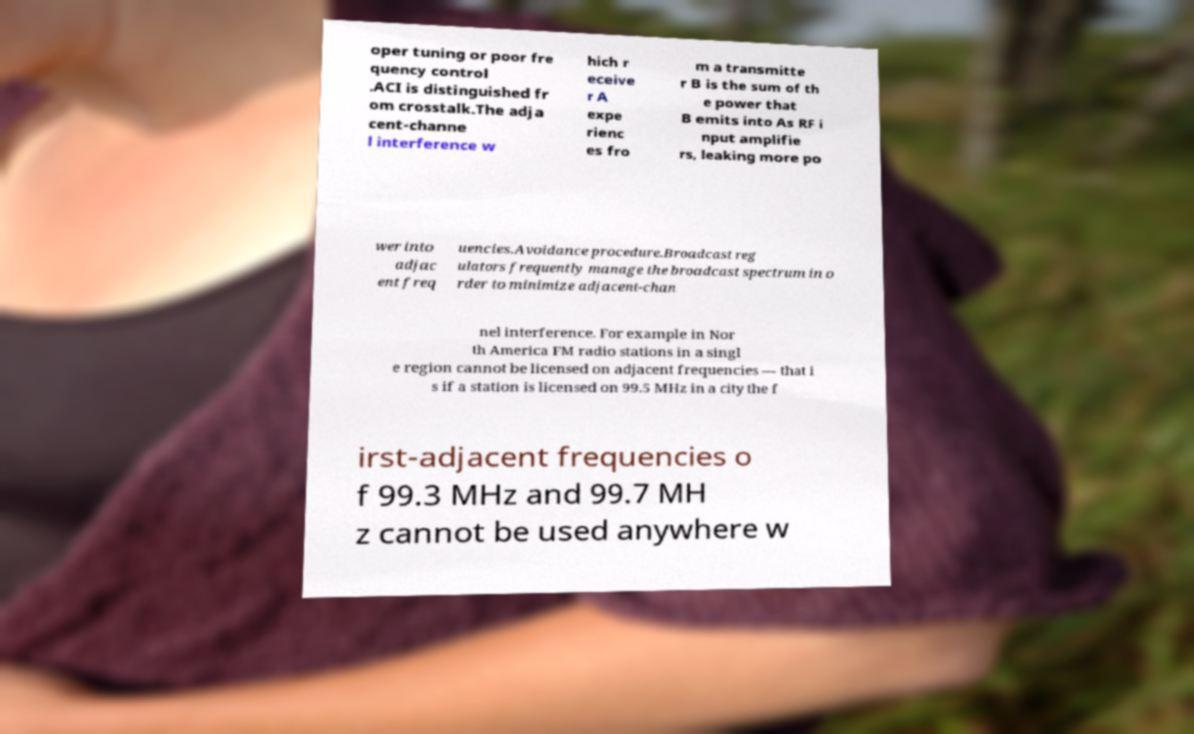Can you read and provide the text displayed in the image?This photo seems to have some interesting text. Can you extract and type it out for me? oper tuning or poor fre quency control .ACI is distinguished fr om crosstalk.The adja cent-channe l interference w hich r eceive r A expe rienc es fro m a transmitte r B is the sum of th e power that B emits into As RF i nput amplifie rs, leaking more po wer into adjac ent freq uencies.Avoidance procedure.Broadcast reg ulators frequently manage the broadcast spectrum in o rder to minimize adjacent-chan nel interference. For example in Nor th America FM radio stations in a singl e region cannot be licensed on adjacent frequencies — that i s if a station is licensed on 99.5 MHz in a city the f irst-adjacent frequencies o f 99.3 MHz and 99.7 MH z cannot be used anywhere w 